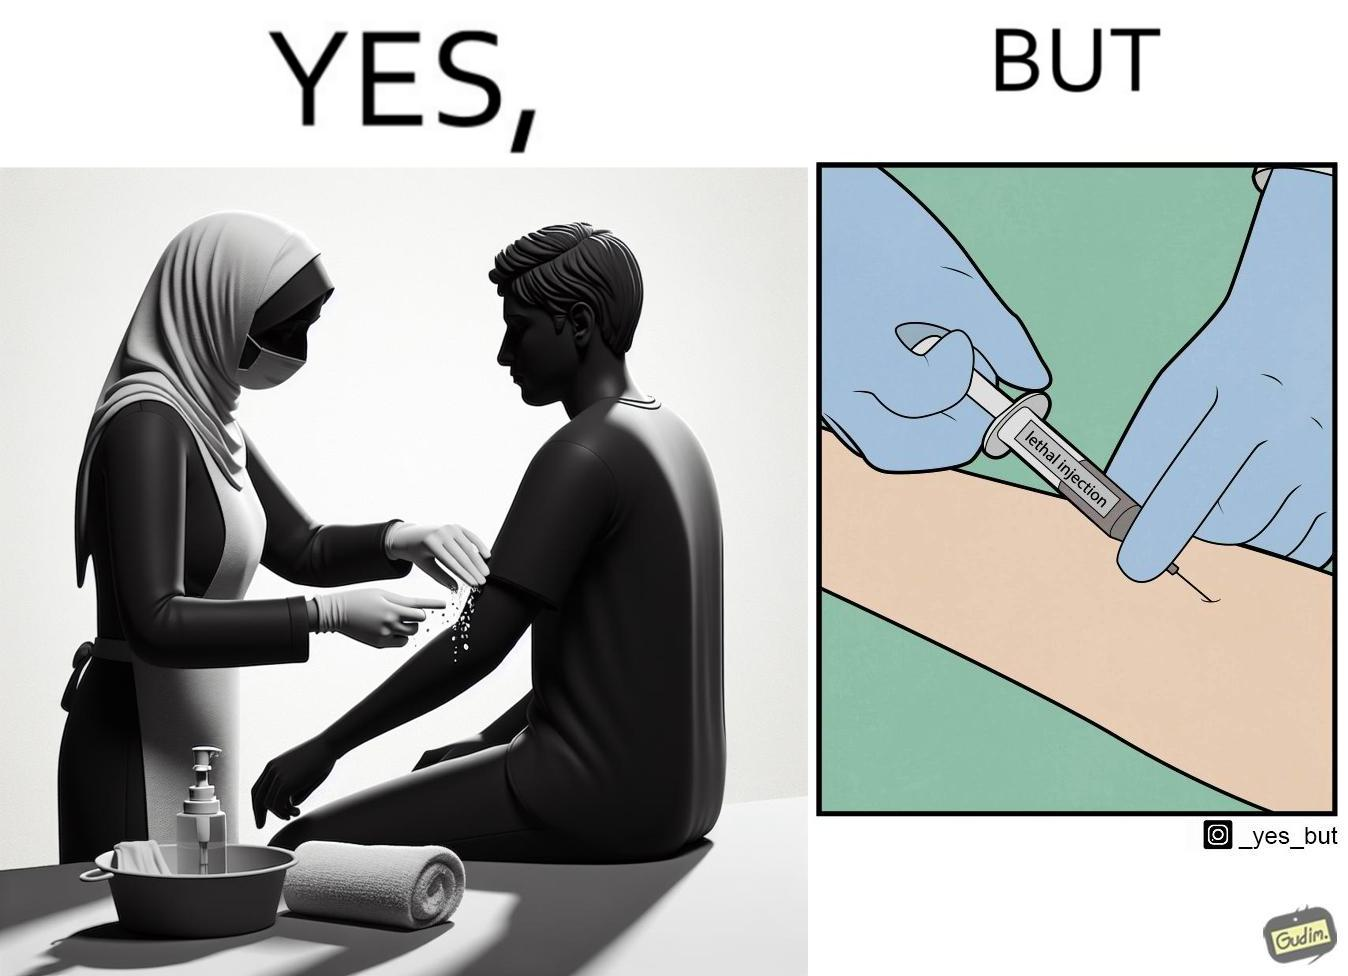Is this image satirical or non-satirical? Yes, this image is satirical. 